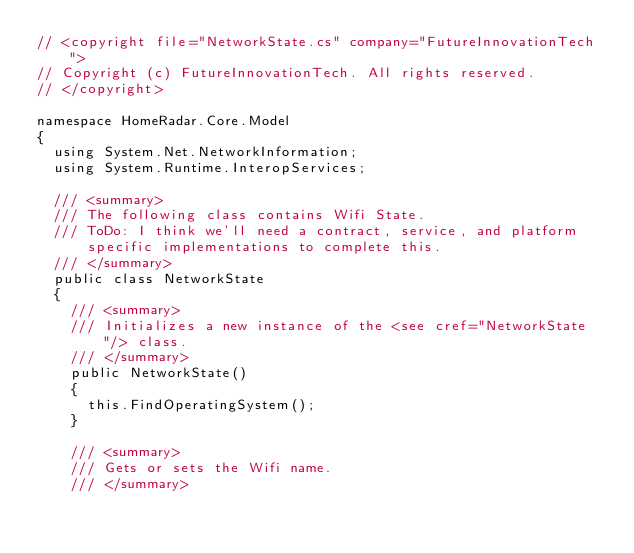Convert code to text. <code><loc_0><loc_0><loc_500><loc_500><_C#_>// <copyright file="NetworkState.cs" company="FutureInnovationTech">
// Copyright (c) FutureInnovationTech. All rights reserved.
// </copyright>

namespace HomeRadar.Core.Model
{
  using System.Net.NetworkInformation;
  using System.Runtime.InteropServices;

  /// <summary>
  /// The following class contains Wifi State.
  /// ToDo: I think we'll need a contract, service, and platform specific implementations to complete this.
  /// </summary>
  public class NetworkState
  {
    /// <summary>
    /// Initializes a new instance of the <see cref="NetworkState"/> class.
    /// </summary>
    public NetworkState()
    {
      this.FindOperatingSystem();
    }

    /// <summary>
    /// Gets or sets the Wifi name.
    /// </summary></code> 